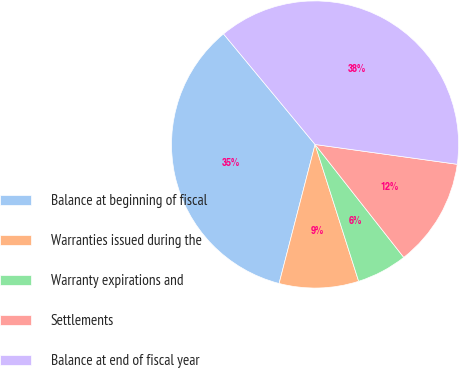Convert chart to OTSL. <chart><loc_0><loc_0><loc_500><loc_500><pie_chart><fcel>Balance at beginning of fiscal<fcel>Warranties issued during the<fcel>Warranty expirations and<fcel>Settlements<fcel>Balance at end of fiscal year<nl><fcel>34.96%<fcel>8.94%<fcel>5.69%<fcel>12.2%<fcel>38.21%<nl></chart> 